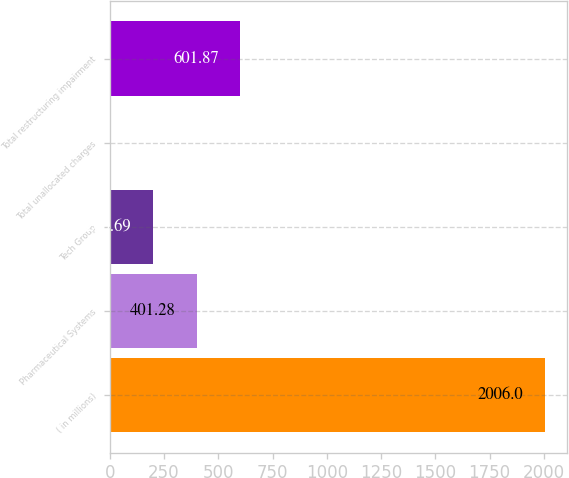Convert chart. <chart><loc_0><loc_0><loc_500><loc_500><bar_chart><fcel>( in millions)<fcel>Pharmaceutical Systems<fcel>Tech Group<fcel>Total unallocated charges<fcel>Total restructuring impairment<nl><fcel>2006<fcel>401.28<fcel>200.69<fcel>0.1<fcel>601.87<nl></chart> 